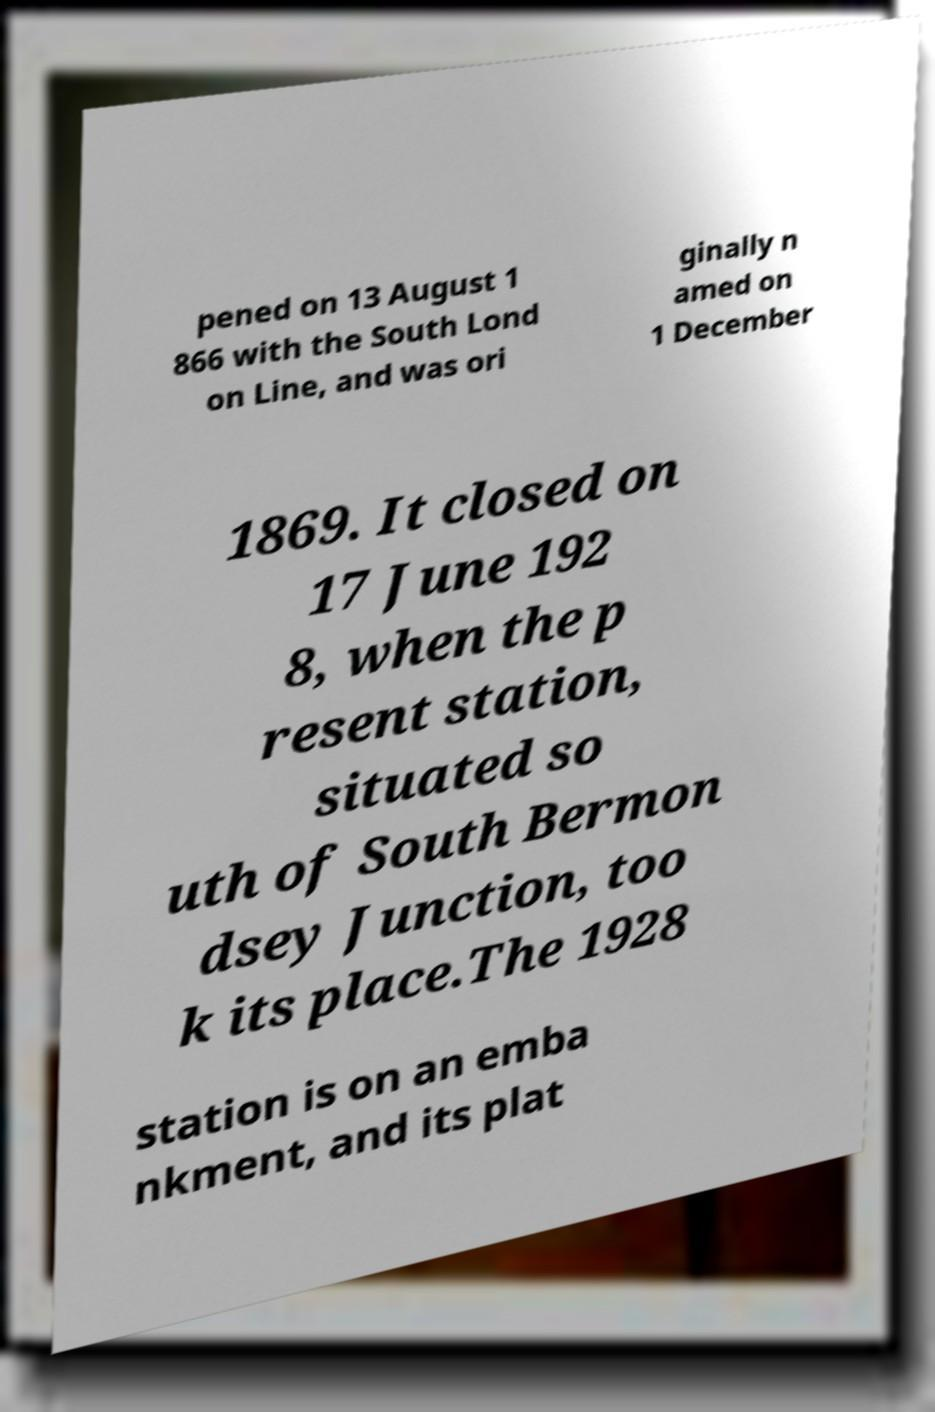Can you accurately transcribe the text from the provided image for me? pened on 13 August 1 866 with the South Lond on Line, and was ori ginally n amed on 1 December 1869. It closed on 17 June 192 8, when the p resent station, situated so uth of South Bermon dsey Junction, too k its place.The 1928 station is on an emba nkment, and its plat 